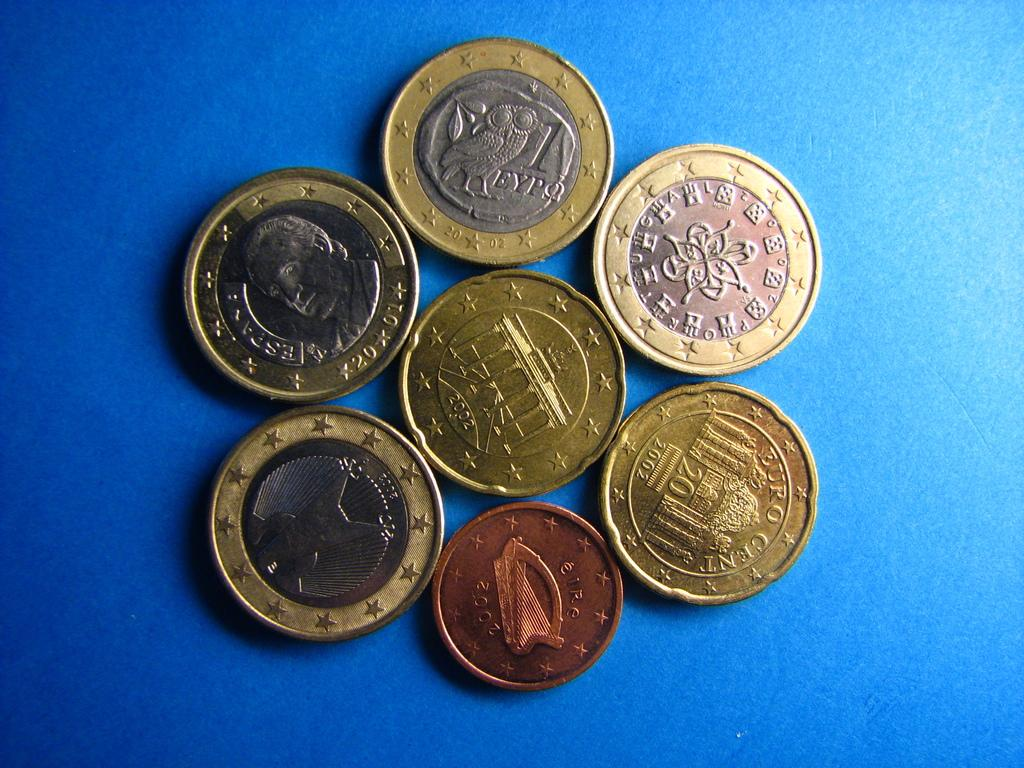What objects are present in the image? There is a group of coins in the image. What is the color of the platform in the image? The platform is blue in color. How many faces can be seen on the coins in the image? There is no information about faces on the coins in the image, as the facts only mention the presence of a group of coins. 